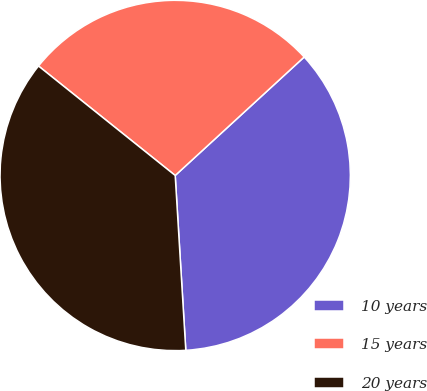Convert chart to OTSL. <chart><loc_0><loc_0><loc_500><loc_500><pie_chart><fcel>10 years<fcel>15 years<fcel>20 years<nl><fcel>35.86%<fcel>27.43%<fcel>36.71%<nl></chart> 